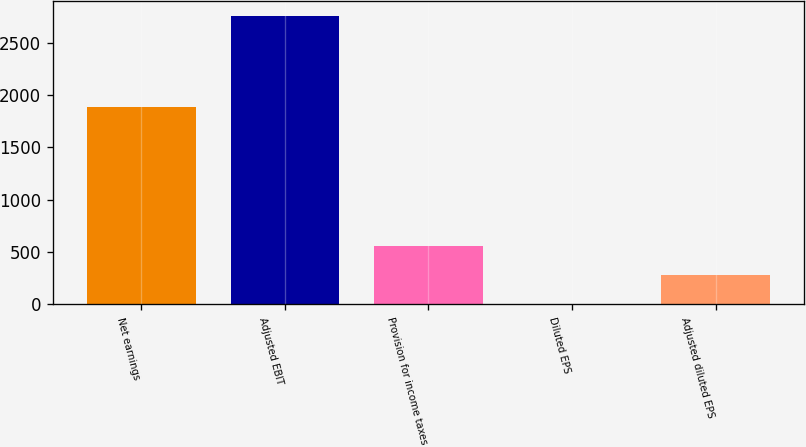<chart> <loc_0><loc_0><loc_500><loc_500><bar_chart><fcel>Net earnings<fcel>Adjusted EBIT<fcel>Provision for income taxes<fcel>Diluted EPS<fcel>Adjusted diluted EPS<nl><fcel>1884.9<fcel>2754.6<fcel>554.33<fcel>4.25<fcel>279.29<nl></chart> 